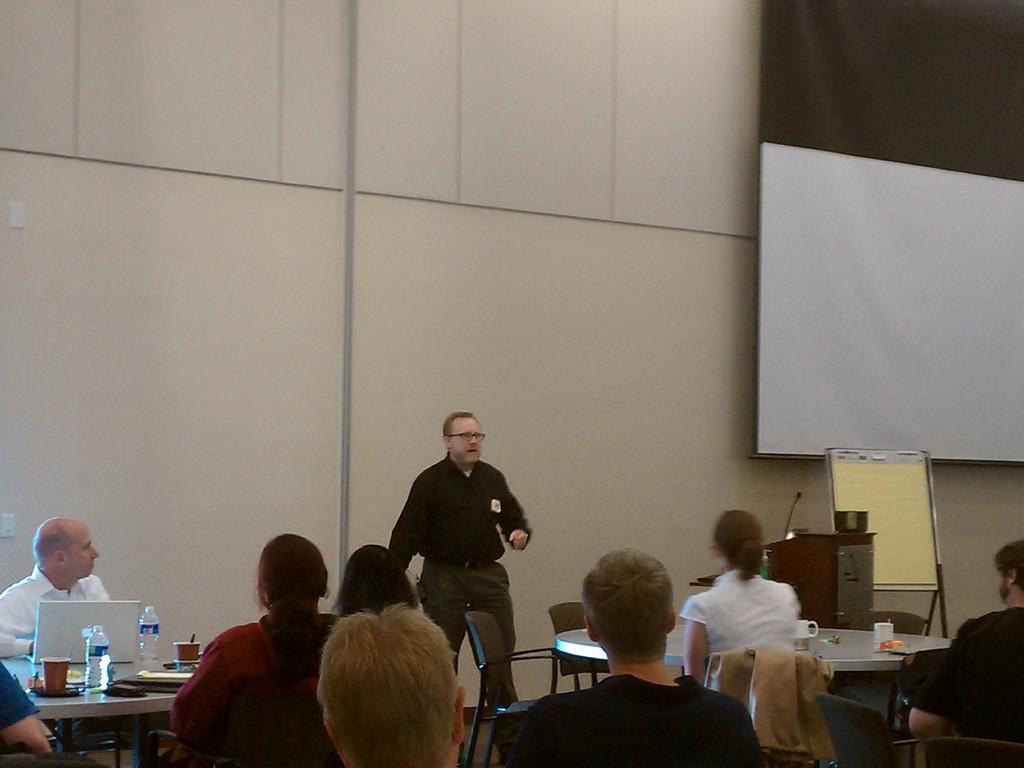How would you summarize this image in a sentence or two? In the middle a man is standing, he wore black color shirt. Here many people are sitting and listening to him. 